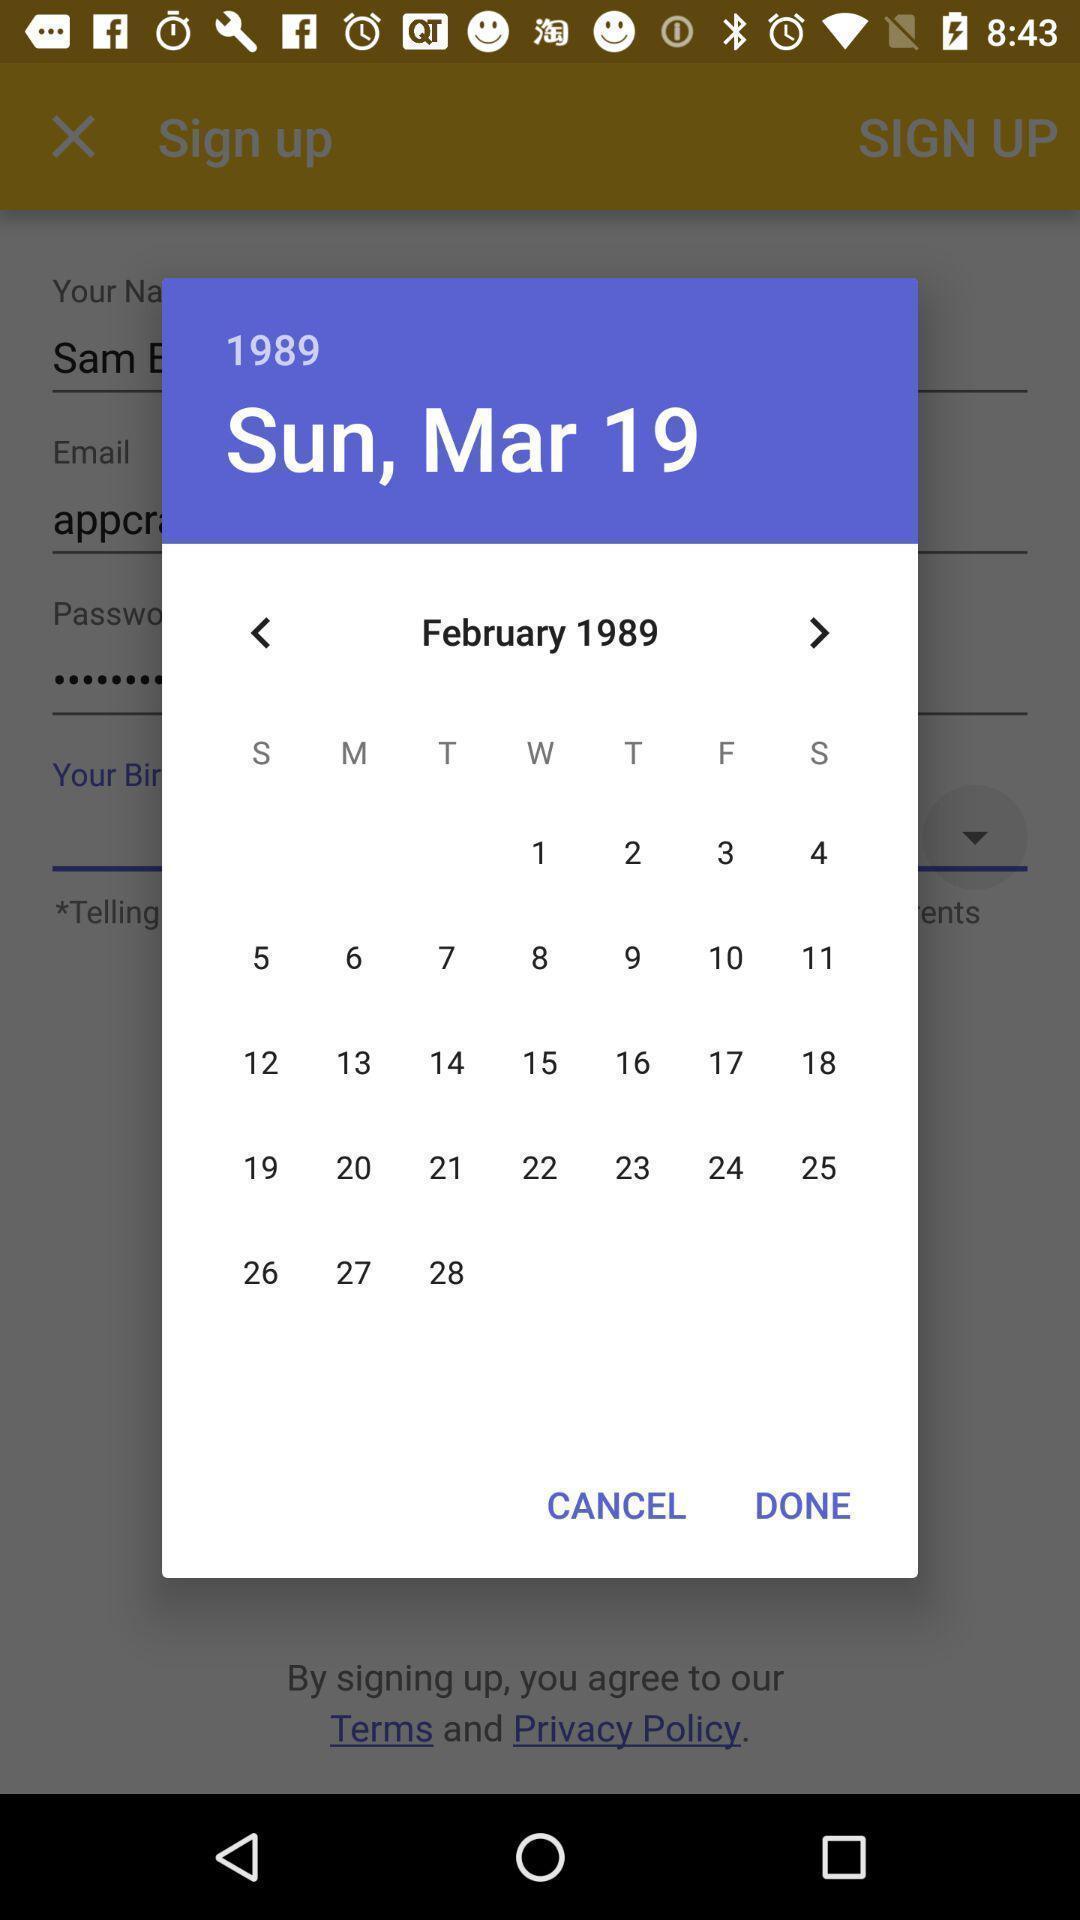Please provide a description for this image. Pop-up displaying the calendar page. 